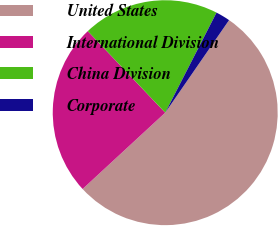<chart> <loc_0><loc_0><loc_500><loc_500><pie_chart><fcel>United States<fcel>International Division<fcel>China Division<fcel>Corporate<nl><fcel>53.52%<fcel>24.78%<fcel>19.63%<fcel>2.07%<nl></chart> 